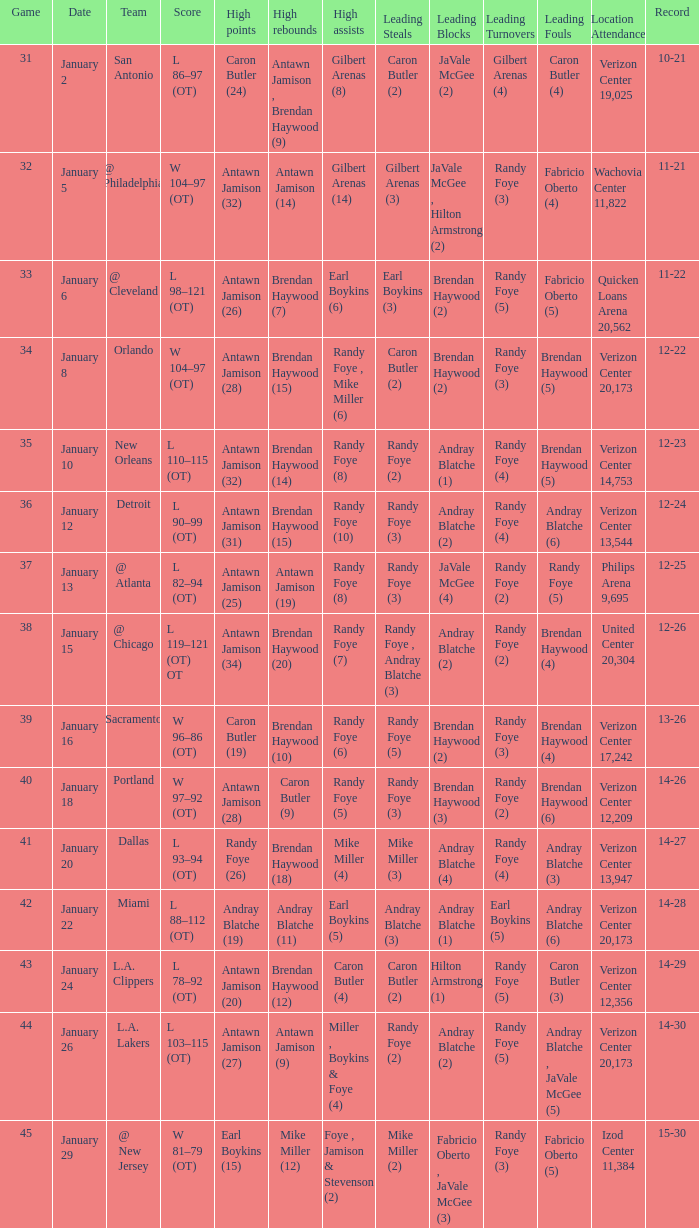How many people got high points in game 35? 1.0. 